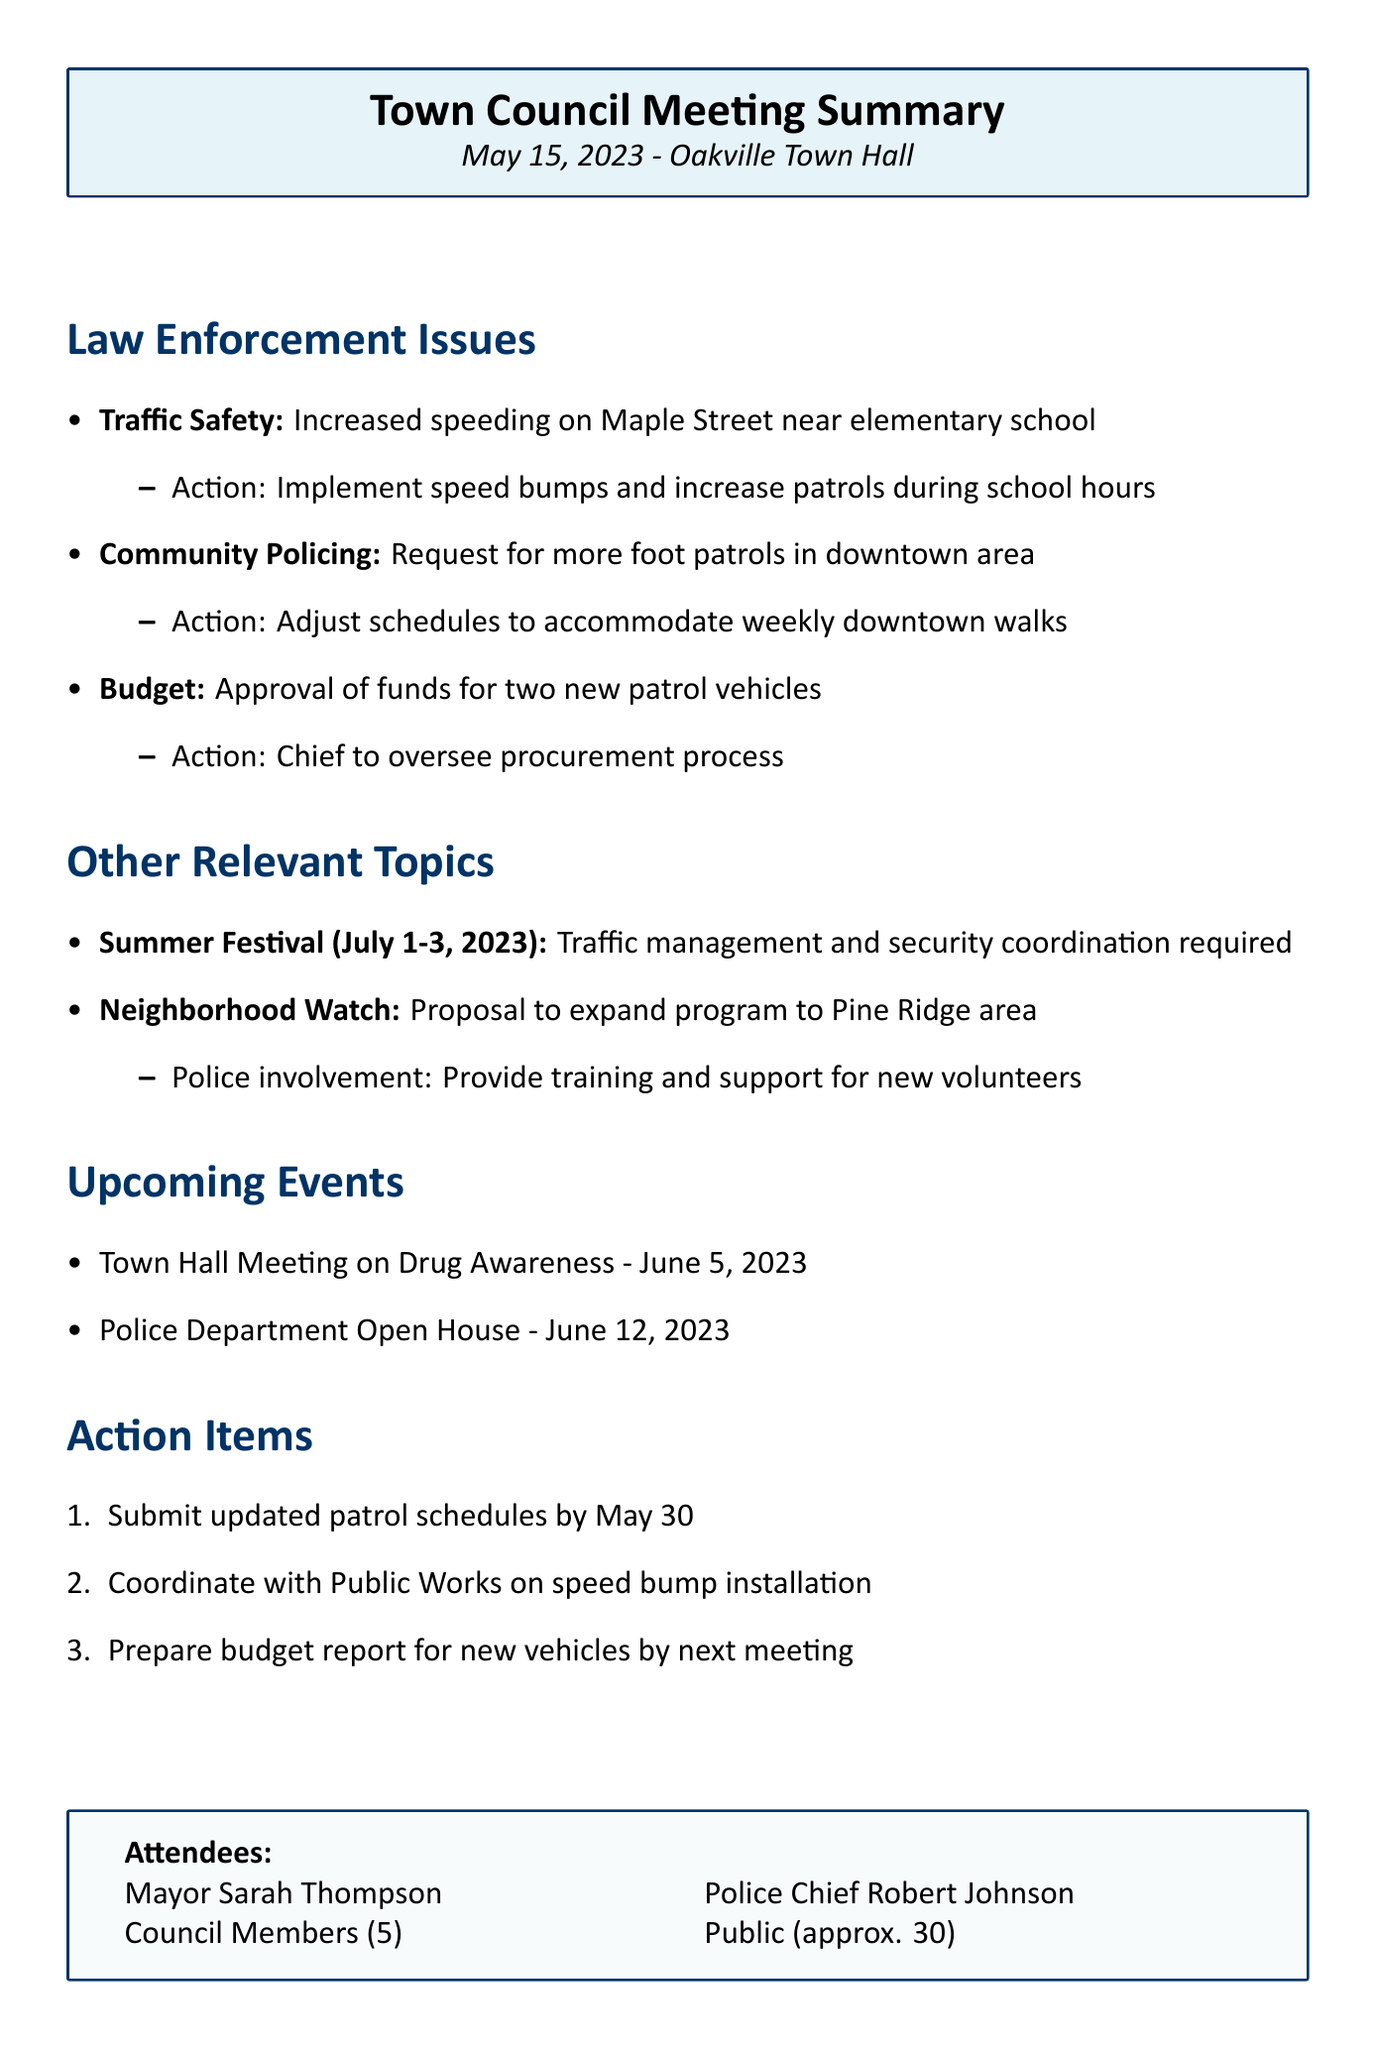What date did the meeting occur? The meeting date is explicitly stated in the document.
Answer: May 15, 2023 Who chaired the meeting? The document names the attendees, including the mayor who chaired the meeting.
Answer: Mayor Sarah Thompson What topic was discussed regarding traffic safety? The specific law enforcement issue highlighted under traffic safety is mentioned directly.
Answer: Increased speeding on Maple Street near elementary school What action was proposed for community policing? The document lists the action items following the discussion on community policing.
Answer: Adjust schedules to accommodate weekly downtown walks How many patrol vehicles were approved in the budget? The document specifically mentions the number of new patrol vehicles to be procured in the budget discussion.
Answer: Two What is the scheduled date for the Town Hall Meeting on Drug Awareness? The upcoming events are clearly outlined with specific dates mentioned.
Answer: June 5, 2023 What is the police involvement in the Summer Festival? The document states the police's role regarding the upcoming Summer Festival event.
Answer: Traffic management and security coordination required What is one of the action items due by May 30? The document lists specific action items to be completed before the next meeting.
Answer: Submit updated patrol schedules What area is proposed for the expansion of the Neighborhood Watch program? The document specifies the location for the proposed expansion of the Neighborhood Watch program.
Answer: Pine Ridge area 